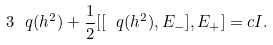<formula> <loc_0><loc_0><loc_500><loc_500>3 \ q ( h ^ { 2 } ) + \frac { 1 } { 2 } [ [ \ q ( h ^ { 2 } ) , E _ { - } ] , E _ { + } ] = c I .</formula> 